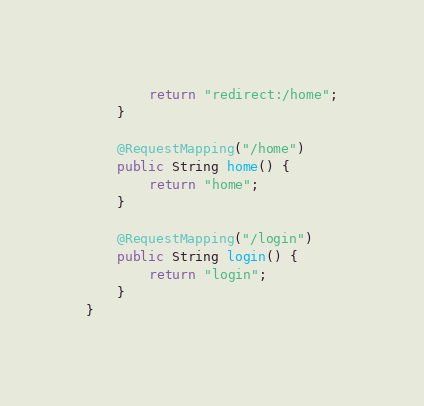Convert code to text. <code><loc_0><loc_0><loc_500><loc_500><_Java_>        return "redirect:/home";
    }

    @RequestMapping("/home")
    public String home() {
        return "home";
    }

    @RequestMapping("/login")
    public String login() {
        return "login";
    }
}</code> 